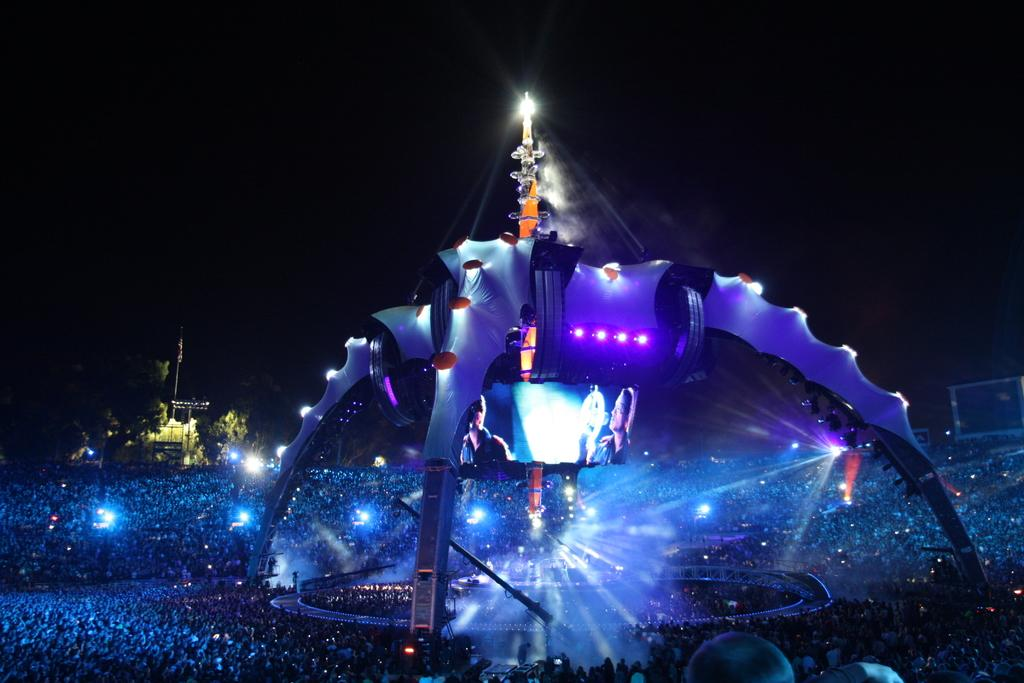How many people are in the group visible in the image? There is a group of people in the image, but the exact number cannot be determined from the provided facts. What can be seen in the image besides the group of people? There are lights, trees, a stage, and objects on the stage visible in the image. What is the color of the lighting on the stage? The lighting on the stage is blue in color. What is the background color of the image? The background of the image is black. What type of mailbox can be seen in the image? There is no mailbox present in the image. What songs are being sung by the group of people in the image? The provided facts do not mention any songs being sung by the group of people in the image. --- Facts: 1. There is a car in the image. 2. The car is red in color. 3. There are people in the car. 4. The car has four wheels. 5. The car has a license plate. 6. The license plate has numbers and letters. Absurd Topics: animals, ocean, waves Conversation: What type of vehicle is in the image? There is a car in the image. What color is the car? The car is red in color. Are there any passengers in the car? Yes, there are people in the car. How many wheels does the car have? The car has four wheels. What is attached to the back of the car? The car has a license plate. What information is displayed on the license plate? The license plate has numbers and letters. Reasoning: Let's think step by step in order to produce the conversation. We start by identifying the main subject in the image, which is the car. Then, we expand the conversation to include other details about the car, such as its color, the presence of passengers, the number of wheels, and the license plate. Each question is designed to elicit a specific detail about the image that is known from the provided facts. Absurd Question/Answer: What type of animals can be seen swimming in the ocean in the image? There is no ocean or animals present in the image; it features a red car with people inside. What type of waves can be seen crashing on the shore in the image? There is no shore or waves present in the image; it features a red car with people inside. 